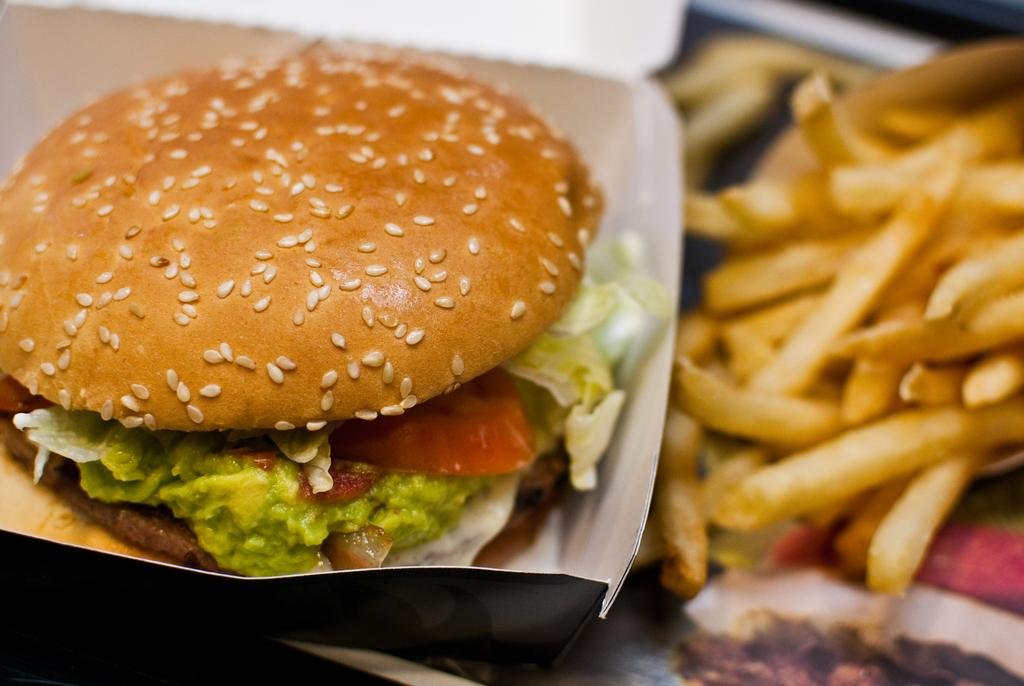What type of food is in the box in the image? There is a burger in the box in the image. What other type of food is visible on the tray? There are french fries on the tray in the image. What type of writing is visible on the government building in the image? There is no government building or writing present in the image; it features a burger in a box and french fries on a tray. What type of learning can be observed in the image? There is no learning activity present in the image; it features a burger in a box and french fries on a tray. 